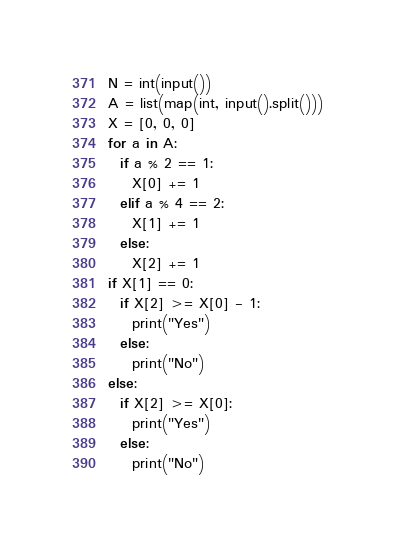<code> <loc_0><loc_0><loc_500><loc_500><_Python_>N = int(input())
A = list(map(int, input().split()))
X = [0, 0, 0]
for a in A:
  if a % 2 == 1:
    X[0] += 1
  elif a % 4 == 2:
    X[1] += 1
  else:
    X[2] += 1
if X[1] == 0:
  if X[2] >= X[0] - 1:
    print("Yes")
  else:
    print("No")
else:
  if X[2] >= X[0]:
    print("Yes")
  else:
    print("No")</code> 